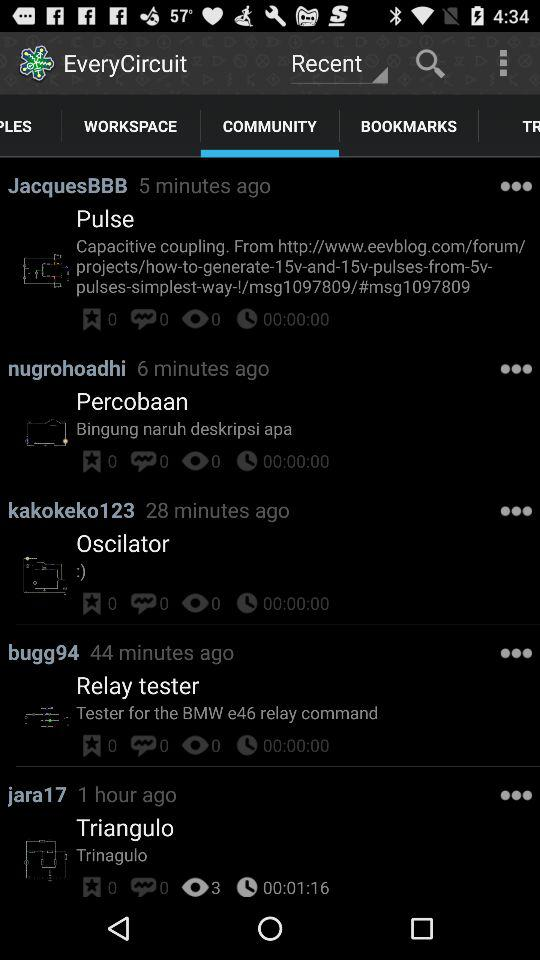How many views are there on "Oscilator"? There are 0 views. 